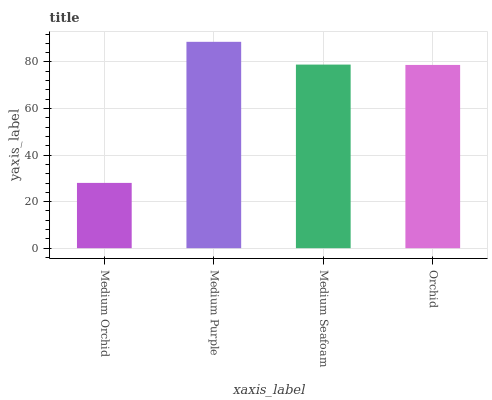Is Medium Orchid the minimum?
Answer yes or no. Yes. Is Medium Purple the maximum?
Answer yes or no. Yes. Is Medium Seafoam the minimum?
Answer yes or no. No. Is Medium Seafoam the maximum?
Answer yes or no. No. Is Medium Purple greater than Medium Seafoam?
Answer yes or no. Yes. Is Medium Seafoam less than Medium Purple?
Answer yes or no. Yes. Is Medium Seafoam greater than Medium Purple?
Answer yes or no. No. Is Medium Purple less than Medium Seafoam?
Answer yes or no. No. Is Medium Seafoam the high median?
Answer yes or no. Yes. Is Orchid the low median?
Answer yes or no. Yes. Is Medium Purple the high median?
Answer yes or no. No. Is Medium Purple the low median?
Answer yes or no. No. 